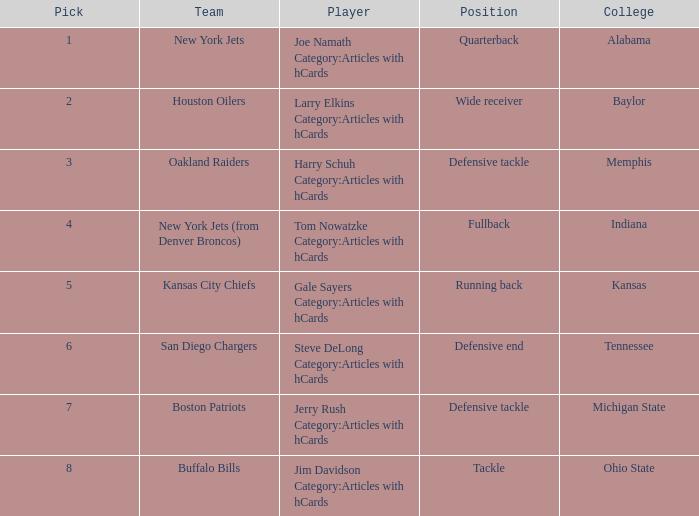Which player is from the College of Alabama? Joe Namath Category:Articles with hCards. 